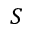<formula> <loc_0><loc_0><loc_500><loc_500>S</formula> 